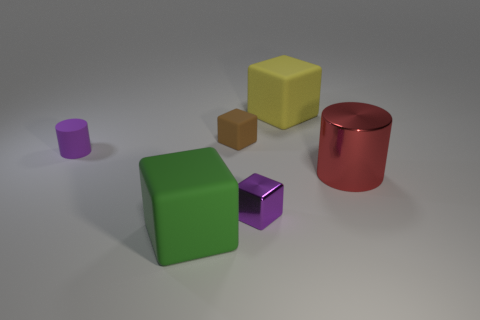Are there any other things that are the same color as the big metal cylinder?
Your answer should be compact. No. What material is the purple thing on the left side of the large rubber object that is in front of the large matte object behind the large red cylinder?
Ensure brevity in your answer.  Rubber. How many metal objects are yellow cylinders or tiny purple objects?
Offer a terse response. 1. What number of yellow objects are large metallic things or large cubes?
Offer a very short reply. 1. There is a cylinder to the right of the big yellow matte cube; is its color the same as the rubber cylinder?
Provide a short and direct response. No. Are the yellow cube and the red cylinder made of the same material?
Your answer should be compact. No. Is the number of tiny purple blocks left of the small matte cylinder the same as the number of big red things in front of the shiny block?
Provide a short and direct response. Yes. There is a brown thing that is the same shape as the big green rubber thing; what is its material?
Offer a terse response. Rubber. There is a big object that is to the right of the big rubber thing that is behind the big matte object in front of the tiny purple cube; what shape is it?
Provide a succinct answer. Cylinder. Is the number of large cylinders in front of the green matte object greater than the number of red cylinders?
Make the answer very short. No. 